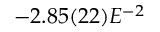Convert formula to latex. <formula><loc_0><loc_0><loc_500><loc_500>- 2 . 8 5 ( 2 2 ) E ^ { - 2 }</formula> 